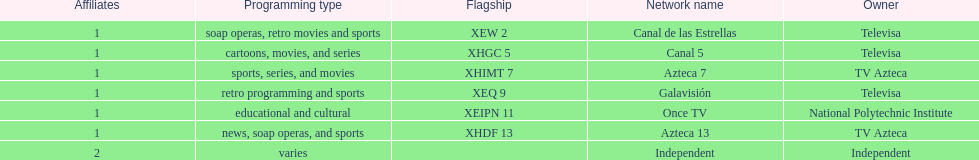Azteca 7 and azteca 13 are both owned by whom? TV Azteca. 